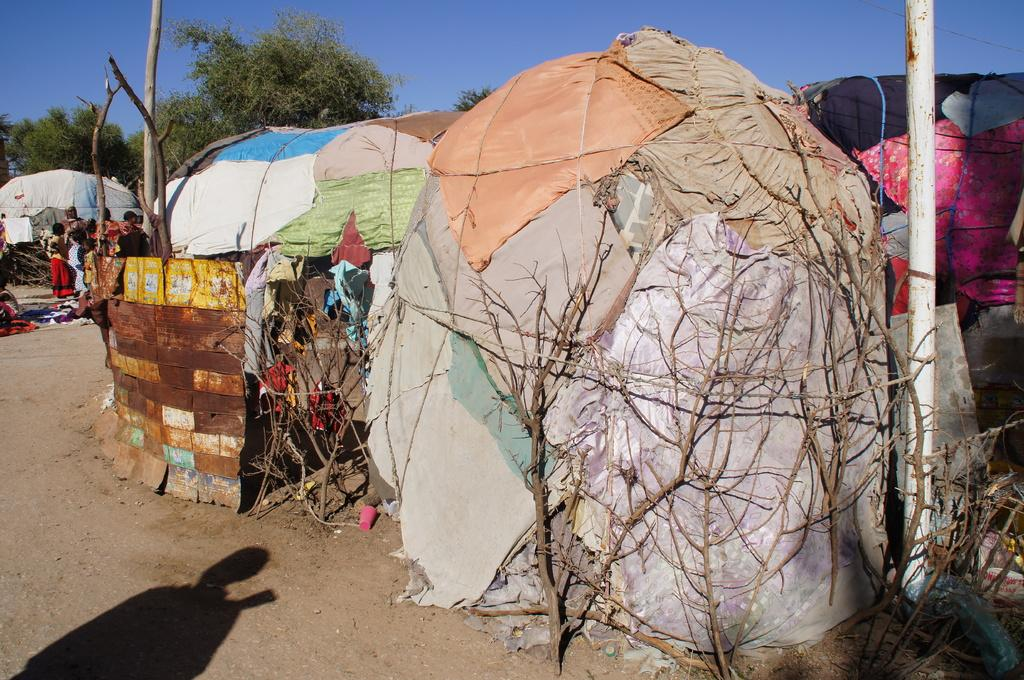What type of structures are made of cloth in the image? There are tents made of cloth in the image. What can be seen connected to the tents in the image? There are stems connected to the tents in the image. Who is present in the image? There are people in the image. What type of natural vegetation is visible in the image? There are trees in the image. What is the pole used for in the image? The pole is likely used to support the tents in the image. What type of business is being conducted in the image? There is no indication of a business being conducted in the image. Can you describe the scarf that is being worn by the person on the side in the image? There is no person wearing a scarf in the image. 